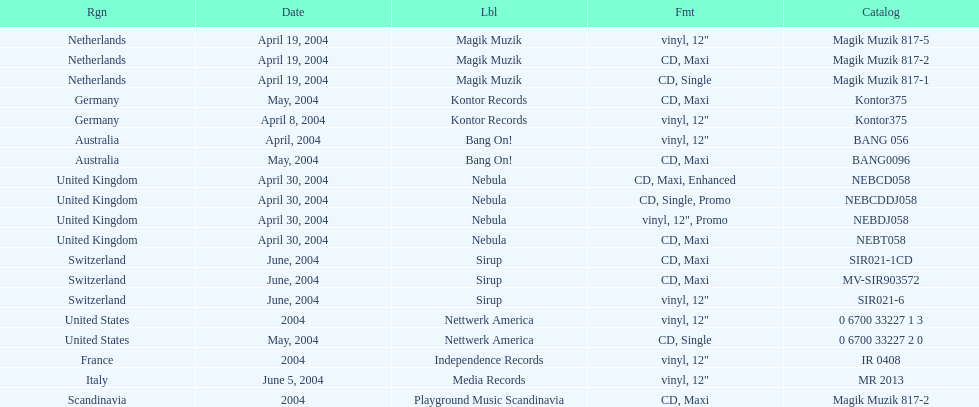What region was in the sir021-1cd catalog? Switzerland. 